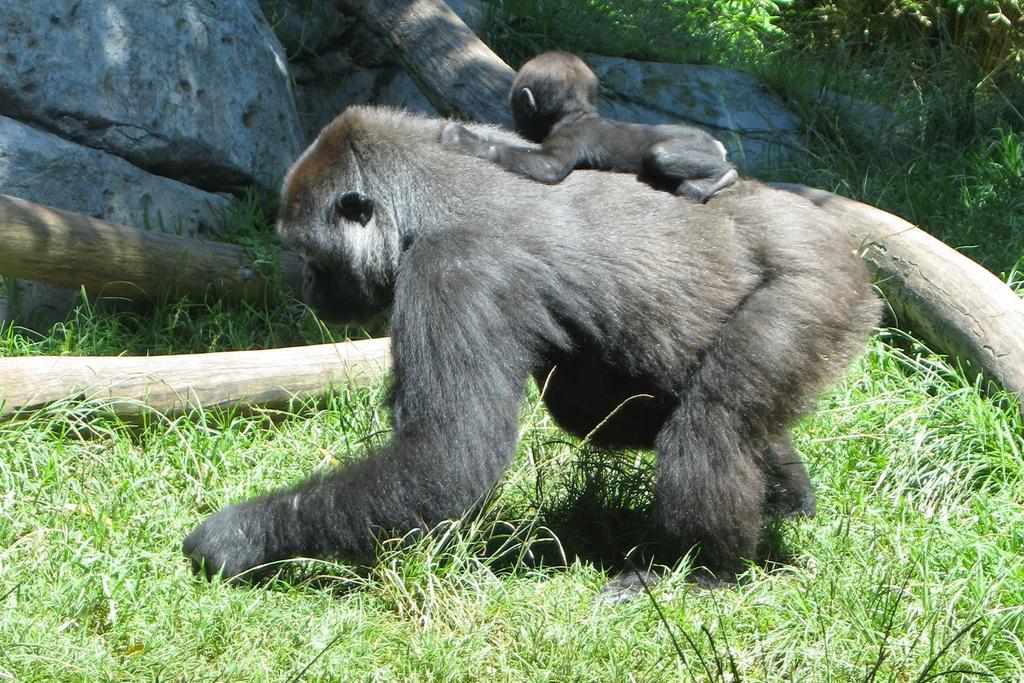Describe this image in one or two sentences. These are monkeys and grass, these are rocks. 